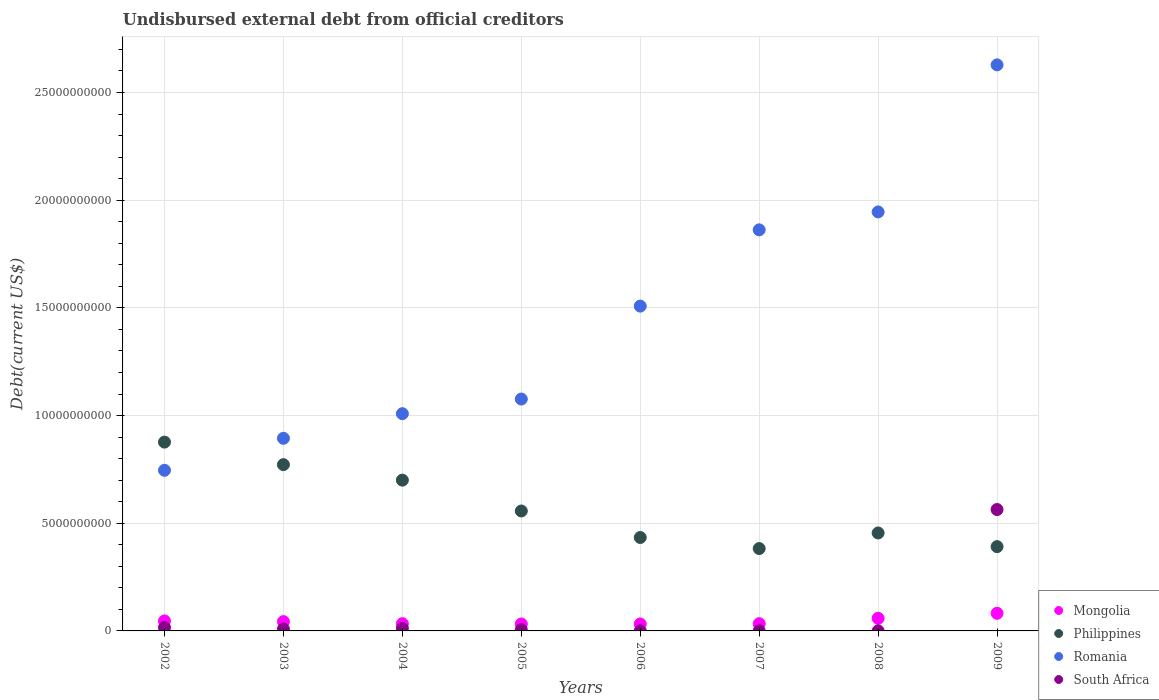What is the total debt in South Africa in 2003?
Ensure brevity in your answer.  8.62e+07. Across all years, what is the maximum total debt in Philippines?
Offer a terse response. 8.77e+09. Across all years, what is the minimum total debt in Romania?
Make the answer very short. 7.46e+09. In which year was the total debt in Romania maximum?
Ensure brevity in your answer.  2009. In which year was the total debt in South Africa minimum?
Offer a terse response. 2008. What is the total total debt in South Africa in the graph?
Make the answer very short. 6.07e+09. What is the difference between the total debt in South Africa in 2003 and that in 2008?
Ensure brevity in your answer.  8.22e+07. What is the difference between the total debt in South Africa in 2003 and the total debt in Romania in 2009?
Make the answer very short. -2.62e+1. What is the average total debt in Mongolia per year?
Provide a succinct answer. 4.52e+08. In the year 2002, what is the difference between the total debt in Mongolia and total debt in South Africa?
Ensure brevity in your answer.  3.06e+08. In how many years, is the total debt in Philippines greater than 26000000000 US$?
Ensure brevity in your answer.  0. What is the ratio of the total debt in Mongolia in 2008 to that in 2009?
Make the answer very short. 0.72. Is the total debt in South Africa in 2002 less than that in 2004?
Offer a very short reply. No. What is the difference between the highest and the second highest total debt in Mongolia?
Ensure brevity in your answer.  2.33e+08. What is the difference between the highest and the lowest total debt in Romania?
Offer a very short reply. 1.88e+1. Is it the case that in every year, the sum of the total debt in Philippines and total debt in Romania  is greater than the total debt in South Africa?
Offer a very short reply. Yes. Is the total debt in Mongolia strictly less than the total debt in South Africa over the years?
Provide a short and direct response. No. Does the graph contain any zero values?
Your response must be concise. No. Does the graph contain grids?
Ensure brevity in your answer.  Yes. Where does the legend appear in the graph?
Provide a succinct answer. Bottom right. How are the legend labels stacked?
Offer a very short reply. Vertical. What is the title of the graph?
Make the answer very short. Undisbursed external debt from official creditors. Does "Austria" appear as one of the legend labels in the graph?
Offer a very short reply. No. What is the label or title of the Y-axis?
Your response must be concise. Debt(current US$). What is the Debt(current US$) in Mongolia in 2002?
Provide a short and direct response. 4.64e+08. What is the Debt(current US$) in Philippines in 2002?
Keep it short and to the point. 8.77e+09. What is the Debt(current US$) of Romania in 2002?
Your response must be concise. 7.46e+09. What is the Debt(current US$) in South Africa in 2002?
Ensure brevity in your answer.  1.59e+08. What is the Debt(current US$) of Mongolia in 2003?
Provide a short and direct response. 4.32e+08. What is the Debt(current US$) of Philippines in 2003?
Offer a very short reply. 7.72e+09. What is the Debt(current US$) of Romania in 2003?
Provide a succinct answer. 8.94e+09. What is the Debt(current US$) in South Africa in 2003?
Provide a short and direct response. 8.62e+07. What is the Debt(current US$) of Mongolia in 2004?
Your answer should be very brief. 3.35e+08. What is the Debt(current US$) in Philippines in 2004?
Ensure brevity in your answer.  7.00e+09. What is the Debt(current US$) of Romania in 2004?
Offer a very short reply. 1.01e+1. What is the Debt(current US$) of South Africa in 2004?
Make the answer very short. 1.16e+08. What is the Debt(current US$) in Mongolia in 2005?
Your answer should be very brief. 3.22e+08. What is the Debt(current US$) of Philippines in 2005?
Offer a very short reply. 5.57e+09. What is the Debt(current US$) in Romania in 2005?
Provide a succinct answer. 1.08e+1. What is the Debt(current US$) of South Africa in 2005?
Provide a short and direct response. 5.70e+07. What is the Debt(current US$) of Mongolia in 2006?
Offer a very short reply. 3.22e+08. What is the Debt(current US$) in Philippines in 2006?
Make the answer very short. 4.34e+09. What is the Debt(current US$) in Romania in 2006?
Your answer should be very brief. 1.51e+1. What is the Debt(current US$) in South Africa in 2006?
Give a very brief answer. 7.04e+06. What is the Debt(current US$) of Mongolia in 2007?
Provide a succinct answer. 3.36e+08. What is the Debt(current US$) of Philippines in 2007?
Give a very brief answer. 3.82e+09. What is the Debt(current US$) in Romania in 2007?
Make the answer very short. 1.86e+1. What is the Debt(current US$) of South Africa in 2007?
Offer a very short reply. 7.04e+06. What is the Debt(current US$) of Mongolia in 2008?
Provide a short and direct response. 5.85e+08. What is the Debt(current US$) in Philippines in 2008?
Your answer should be compact. 4.55e+09. What is the Debt(current US$) of Romania in 2008?
Keep it short and to the point. 1.95e+1. What is the Debt(current US$) in South Africa in 2008?
Offer a terse response. 3.94e+06. What is the Debt(current US$) of Mongolia in 2009?
Offer a very short reply. 8.19e+08. What is the Debt(current US$) of Philippines in 2009?
Keep it short and to the point. 3.91e+09. What is the Debt(current US$) in Romania in 2009?
Provide a short and direct response. 2.63e+1. What is the Debt(current US$) in South Africa in 2009?
Provide a succinct answer. 5.64e+09. Across all years, what is the maximum Debt(current US$) in Mongolia?
Offer a very short reply. 8.19e+08. Across all years, what is the maximum Debt(current US$) of Philippines?
Your answer should be very brief. 8.77e+09. Across all years, what is the maximum Debt(current US$) in Romania?
Provide a succinct answer. 2.63e+1. Across all years, what is the maximum Debt(current US$) of South Africa?
Ensure brevity in your answer.  5.64e+09. Across all years, what is the minimum Debt(current US$) in Mongolia?
Offer a very short reply. 3.22e+08. Across all years, what is the minimum Debt(current US$) in Philippines?
Your answer should be very brief. 3.82e+09. Across all years, what is the minimum Debt(current US$) of Romania?
Provide a short and direct response. 7.46e+09. Across all years, what is the minimum Debt(current US$) in South Africa?
Give a very brief answer. 3.94e+06. What is the total Debt(current US$) in Mongolia in the graph?
Offer a terse response. 3.62e+09. What is the total Debt(current US$) in Philippines in the graph?
Your response must be concise. 4.57e+1. What is the total Debt(current US$) of Romania in the graph?
Keep it short and to the point. 1.17e+11. What is the total Debt(current US$) of South Africa in the graph?
Make the answer very short. 6.07e+09. What is the difference between the Debt(current US$) in Mongolia in 2002 and that in 2003?
Your answer should be very brief. 3.22e+07. What is the difference between the Debt(current US$) in Philippines in 2002 and that in 2003?
Provide a succinct answer. 1.05e+09. What is the difference between the Debt(current US$) in Romania in 2002 and that in 2003?
Keep it short and to the point. -1.49e+09. What is the difference between the Debt(current US$) of South Africa in 2002 and that in 2003?
Ensure brevity in your answer.  7.24e+07. What is the difference between the Debt(current US$) in Mongolia in 2002 and that in 2004?
Ensure brevity in your answer.  1.29e+08. What is the difference between the Debt(current US$) in Philippines in 2002 and that in 2004?
Your answer should be compact. 1.77e+09. What is the difference between the Debt(current US$) of Romania in 2002 and that in 2004?
Provide a short and direct response. -2.63e+09. What is the difference between the Debt(current US$) in South Africa in 2002 and that in 2004?
Give a very brief answer. 4.22e+07. What is the difference between the Debt(current US$) in Mongolia in 2002 and that in 2005?
Offer a very short reply. 1.42e+08. What is the difference between the Debt(current US$) of Philippines in 2002 and that in 2005?
Your answer should be compact. 3.20e+09. What is the difference between the Debt(current US$) in Romania in 2002 and that in 2005?
Ensure brevity in your answer.  -3.31e+09. What is the difference between the Debt(current US$) in South Africa in 2002 and that in 2005?
Provide a short and direct response. 1.02e+08. What is the difference between the Debt(current US$) in Mongolia in 2002 and that in 2006?
Keep it short and to the point. 1.42e+08. What is the difference between the Debt(current US$) in Philippines in 2002 and that in 2006?
Your answer should be compact. 4.43e+09. What is the difference between the Debt(current US$) of Romania in 2002 and that in 2006?
Ensure brevity in your answer.  -7.62e+09. What is the difference between the Debt(current US$) of South Africa in 2002 and that in 2006?
Your answer should be compact. 1.52e+08. What is the difference between the Debt(current US$) of Mongolia in 2002 and that in 2007?
Ensure brevity in your answer.  1.29e+08. What is the difference between the Debt(current US$) of Philippines in 2002 and that in 2007?
Your answer should be very brief. 4.94e+09. What is the difference between the Debt(current US$) of Romania in 2002 and that in 2007?
Your response must be concise. -1.12e+1. What is the difference between the Debt(current US$) of South Africa in 2002 and that in 2007?
Give a very brief answer. 1.52e+08. What is the difference between the Debt(current US$) of Mongolia in 2002 and that in 2008?
Provide a succinct answer. -1.21e+08. What is the difference between the Debt(current US$) of Philippines in 2002 and that in 2008?
Your answer should be compact. 4.22e+09. What is the difference between the Debt(current US$) in Romania in 2002 and that in 2008?
Keep it short and to the point. -1.20e+1. What is the difference between the Debt(current US$) in South Africa in 2002 and that in 2008?
Give a very brief answer. 1.55e+08. What is the difference between the Debt(current US$) in Mongolia in 2002 and that in 2009?
Keep it short and to the point. -3.55e+08. What is the difference between the Debt(current US$) in Philippines in 2002 and that in 2009?
Your answer should be very brief. 4.85e+09. What is the difference between the Debt(current US$) in Romania in 2002 and that in 2009?
Make the answer very short. -1.88e+1. What is the difference between the Debt(current US$) of South Africa in 2002 and that in 2009?
Ensure brevity in your answer.  -5.48e+09. What is the difference between the Debt(current US$) of Mongolia in 2003 and that in 2004?
Provide a short and direct response. 9.66e+07. What is the difference between the Debt(current US$) in Philippines in 2003 and that in 2004?
Your answer should be very brief. 7.19e+08. What is the difference between the Debt(current US$) in Romania in 2003 and that in 2004?
Provide a succinct answer. -1.14e+09. What is the difference between the Debt(current US$) of South Africa in 2003 and that in 2004?
Offer a terse response. -3.02e+07. What is the difference between the Debt(current US$) in Mongolia in 2003 and that in 2005?
Your response must be concise. 1.10e+08. What is the difference between the Debt(current US$) of Philippines in 2003 and that in 2005?
Make the answer very short. 2.15e+09. What is the difference between the Debt(current US$) of Romania in 2003 and that in 2005?
Provide a short and direct response. -1.82e+09. What is the difference between the Debt(current US$) in South Africa in 2003 and that in 2005?
Provide a succinct answer. 2.91e+07. What is the difference between the Debt(current US$) of Mongolia in 2003 and that in 2006?
Ensure brevity in your answer.  1.10e+08. What is the difference between the Debt(current US$) of Philippines in 2003 and that in 2006?
Your answer should be very brief. 3.38e+09. What is the difference between the Debt(current US$) of Romania in 2003 and that in 2006?
Offer a very short reply. -6.14e+09. What is the difference between the Debt(current US$) in South Africa in 2003 and that in 2006?
Offer a very short reply. 7.91e+07. What is the difference between the Debt(current US$) of Mongolia in 2003 and that in 2007?
Your response must be concise. 9.64e+07. What is the difference between the Debt(current US$) in Philippines in 2003 and that in 2007?
Your answer should be very brief. 3.90e+09. What is the difference between the Debt(current US$) of Romania in 2003 and that in 2007?
Keep it short and to the point. -9.68e+09. What is the difference between the Debt(current US$) of South Africa in 2003 and that in 2007?
Offer a very short reply. 7.91e+07. What is the difference between the Debt(current US$) of Mongolia in 2003 and that in 2008?
Provide a short and direct response. -1.54e+08. What is the difference between the Debt(current US$) of Philippines in 2003 and that in 2008?
Ensure brevity in your answer.  3.17e+09. What is the difference between the Debt(current US$) of Romania in 2003 and that in 2008?
Offer a very short reply. -1.05e+1. What is the difference between the Debt(current US$) in South Africa in 2003 and that in 2008?
Your answer should be compact. 8.22e+07. What is the difference between the Debt(current US$) in Mongolia in 2003 and that in 2009?
Your response must be concise. -3.87e+08. What is the difference between the Debt(current US$) in Philippines in 2003 and that in 2009?
Your answer should be very brief. 3.81e+09. What is the difference between the Debt(current US$) of Romania in 2003 and that in 2009?
Your response must be concise. -1.73e+1. What is the difference between the Debt(current US$) of South Africa in 2003 and that in 2009?
Offer a very short reply. -5.55e+09. What is the difference between the Debt(current US$) of Mongolia in 2004 and that in 2005?
Your answer should be very brief. 1.33e+07. What is the difference between the Debt(current US$) of Philippines in 2004 and that in 2005?
Ensure brevity in your answer.  1.43e+09. What is the difference between the Debt(current US$) in Romania in 2004 and that in 2005?
Your answer should be compact. -6.80e+08. What is the difference between the Debt(current US$) of South Africa in 2004 and that in 2005?
Your answer should be compact. 5.94e+07. What is the difference between the Debt(current US$) in Mongolia in 2004 and that in 2006?
Ensure brevity in your answer.  1.32e+07. What is the difference between the Debt(current US$) in Philippines in 2004 and that in 2006?
Make the answer very short. 2.66e+09. What is the difference between the Debt(current US$) in Romania in 2004 and that in 2006?
Keep it short and to the point. -4.99e+09. What is the difference between the Debt(current US$) of South Africa in 2004 and that in 2006?
Ensure brevity in your answer.  1.09e+08. What is the difference between the Debt(current US$) in Mongolia in 2004 and that in 2007?
Keep it short and to the point. -2.40e+05. What is the difference between the Debt(current US$) of Philippines in 2004 and that in 2007?
Give a very brief answer. 3.18e+09. What is the difference between the Debt(current US$) of Romania in 2004 and that in 2007?
Offer a terse response. -8.54e+09. What is the difference between the Debt(current US$) of South Africa in 2004 and that in 2007?
Offer a very short reply. 1.09e+08. What is the difference between the Debt(current US$) of Mongolia in 2004 and that in 2008?
Your answer should be very brief. -2.50e+08. What is the difference between the Debt(current US$) of Philippines in 2004 and that in 2008?
Your response must be concise. 2.45e+09. What is the difference between the Debt(current US$) in Romania in 2004 and that in 2008?
Provide a succinct answer. -9.37e+09. What is the difference between the Debt(current US$) of South Africa in 2004 and that in 2008?
Offer a terse response. 1.12e+08. What is the difference between the Debt(current US$) of Mongolia in 2004 and that in 2009?
Give a very brief answer. -4.83e+08. What is the difference between the Debt(current US$) in Philippines in 2004 and that in 2009?
Give a very brief answer. 3.09e+09. What is the difference between the Debt(current US$) of Romania in 2004 and that in 2009?
Ensure brevity in your answer.  -1.62e+1. What is the difference between the Debt(current US$) in South Africa in 2004 and that in 2009?
Your answer should be compact. -5.52e+09. What is the difference between the Debt(current US$) of Mongolia in 2005 and that in 2006?
Your response must be concise. -1.44e+05. What is the difference between the Debt(current US$) of Philippines in 2005 and that in 2006?
Give a very brief answer. 1.23e+09. What is the difference between the Debt(current US$) in Romania in 2005 and that in 2006?
Offer a very short reply. -4.31e+09. What is the difference between the Debt(current US$) in Mongolia in 2005 and that in 2007?
Your answer should be very brief. -1.35e+07. What is the difference between the Debt(current US$) of Philippines in 2005 and that in 2007?
Provide a short and direct response. 1.74e+09. What is the difference between the Debt(current US$) in Romania in 2005 and that in 2007?
Offer a very short reply. -7.86e+09. What is the difference between the Debt(current US$) in South Africa in 2005 and that in 2007?
Your answer should be very brief. 5.00e+07. What is the difference between the Debt(current US$) of Mongolia in 2005 and that in 2008?
Your answer should be compact. -2.63e+08. What is the difference between the Debt(current US$) in Philippines in 2005 and that in 2008?
Your answer should be compact. 1.02e+09. What is the difference between the Debt(current US$) of Romania in 2005 and that in 2008?
Give a very brief answer. -8.69e+09. What is the difference between the Debt(current US$) of South Africa in 2005 and that in 2008?
Provide a succinct answer. 5.31e+07. What is the difference between the Debt(current US$) in Mongolia in 2005 and that in 2009?
Provide a succinct answer. -4.97e+08. What is the difference between the Debt(current US$) in Philippines in 2005 and that in 2009?
Ensure brevity in your answer.  1.65e+09. What is the difference between the Debt(current US$) of Romania in 2005 and that in 2009?
Ensure brevity in your answer.  -1.55e+1. What is the difference between the Debt(current US$) of South Africa in 2005 and that in 2009?
Provide a succinct answer. -5.58e+09. What is the difference between the Debt(current US$) of Mongolia in 2006 and that in 2007?
Provide a short and direct response. -1.34e+07. What is the difference between the Debt(current US$) in Philippines in 2006 and that in 2007?
Keep it short and to the point. 5.13e+08. What is the difference between the Debt(current US$) in Romania in 2006 and that in 2007?
Offer a terse response. -3.54e+09. What is the difference between the Debt(current US$) in South Africa in 2006 and that in 2007?
Ensure brevity in your answer.  0. What is the difference between the Debt(current US$) of Mongolia in 2006 and that in 2008?
Make the answer very short. -2.63e+08. What is the difference between the Debt(current US$) of Philippines in 2006 and that in 2008?
Make the answer very short. -2.11e+08. What is the difference between the Debt(current US$) in Romania in 2006 and that in 2008?
Keep it short and to the point. -4.37e+09. What is the difference between the Debt(current US$) in South Africa in 2006 and that in 2008?
Give a very brief answer. 3.10e+06. What is the difference between the Debt(current US$) of Mongolia in 2006 and that in 2009?
Provide a short and direct response. -4.97e+08. What is the difference between the Debt(current US$) in Philippines in 2006 and that in 2009?
Offer a terse response. 4.24e+08. What is the difference between the Debt(current US$) of Romania in 2006 and that in 2009?
Your answer should be very brief. -1.12e+1. What is the difference between the Debt(current US$) of South Africa in 2006 and that in 2009?
Keep it short and to the point. -5.63e+09. What is the difference between the Debt(current US$) of Mongolia in 2007 and that in 2008?
Provide a succinct answer. -2.50e+08. What is the difference between the Debt(current US$) in Philippines in 2007 and that in 2008?
Your answer should be compact. -7.24e+08. What is the difference between the Debt(current US$) in Romania in 2007 and that in 2008?
Offer a very short reply. -8.32e+08. What is the difference between the Debt(current US$) in South Africa in 2007 and that in 2008?
Give a very brief answer. 3.10e+06. What is the difference between the Debt(current US$) in Mongolia in 2007 and that in 2009?
Offer a terse response. -4.83e+08. What is the difference between the Debt(current US$) of Philippines in 2007 and that in 2009?
Your answer should be very brief. -8.90e+07. What is the difference between the Debt(current US$) of Romania in 2007 and that in 2009?
Your answer should be compact. -7.66e+09. What is the difference between the Debt(current US$) of South Africa in 2007 and that in 2009?
Your answer should be very brief. -5.63e+09. What is the difference between the Debt(current US$) of Mongolia in 2008 and that in 2009?
Provide a short and direct response. -2.33e+08. What is the difference between the Debt(current US$) in Philippines in 2008 and that in 2009?
Give a very brief answer. 6.35e+08. What is the difference between the Debt(current US$) of Romania in 2008 and that in 2009?
Provide a short and direct response. -6.83e+09. What is the difference between the Debt(current US$) in South Africa in 2008 and that in 2009?
Your answer should be compact. -5.63e+09. What is the difference between the Debt(current US$) in Mongolia in 2002 and the Debt(current US$) in Philippines in 2003?
Offer a very short reply. -7.26e+09. What is the difference between the Debt(current US$) in Mongolia in 2002 and the Debt(current US$) in Romania in 2003?
Keep it short and to the point. -8.48e+09. What is the difference between the Debt(current US$) of Mongolia in 2002 and the Debt(current US$) of South Africa in 2003?
Keep it short and to the point. 3.78e+08. What is the difference between the Debt(current US$) of Philippines in 2002 and the Debt(current US$) of Romania in 2003?
Offer a terse response. -1.77e+08. What is the difference between the Debt(current US$) in Philippines in 2002 and the Debt(current US$) in South Africa in 2003?
Your answer should be very brief. 8.68e+09. What is the difference between the Debt(current US$) in Romania in 2002 and the Debt(current US$) in South Africa in 2003?
Make the answer very short. 7.37e+09. What is the difference between the Debt(current US$) in Mongolia in 2002 and the Debt(current US$) in Philippines in 2004?
Give a very brief answer. -6.54e+09. What is the difference between the Debt(current US$) in Mongolia in 2002 and the Debt(current US$) in Romania in 2004?
Give a very brief answer. -9.62e+09. What is the difference between the Debt(current US$) of Mongolia in 2002 and the Debt(current US$) of South Africa in 2004?
Keep it short and to the point. 3.48e+08. What is the difference between the Debt(current US$) of Philippines in 2002 and the Debt(current US$) of Romania in 2004?
Your answer should be very brief. -1.32e+09. What is the difference between the Debt(current US$) of Philippines in 2002 and the Debt(current US$) of South Africa in 2004?
Offer a terse response. 8.65e+09. What is the difference between the Debt(current US$) in Romania in 2002 and the Debt(current US$) in South Africa in 2004?
Ensure brevity in your answer.  7.34e+09. What is the difference between the Debt(current US$) in Mongolia in 2002 and the Debt(current US$) in Philippines in 2005?
Your response must be concise. -5.10e+09. What is the difference between the Debt(current US$) of Mongolia in 2002 and the Debt(current US$) of Romania in 2005?
Your response must be concise. -1.03e+1. What is the difference between the Debt(current US$) in Mongolia in 2002 and the Debt(current US$) in South Africa in 2005?
Your answer should be compact. 4.07e+08. What is the difference between the Debt(current US$) of Philippines in 2002 and the Debt(current US$) of Romania in 2005?
Offer a terse response. -2.00e+09. What is the difference between the Debt(current US$) of Philippines in 2002 and the Debt(current US$) of South Africa in 2005?
Give a very brief answer. 8.71e+09. What is the difference between the Debt(current US$) of Romania in 2002 and the Debt(current US$) of South Africa in 2005?
Offer a very short reply. 7.40e+09. What is the difference between the Debt(current US$) of Mongolia in 2002 and the Debt(current US$) of Philippines in 2006?
Your answer should be compact. -3.87e+09. What is the difference between the Debt(current US$) in Mongolia in 2002 and the Debt(current US$) in Romania in 2006?
Provide a succinct answer. -1.46e+1. What is the difference between the Debt(current US$) of Mongolia in 2002 and the Debt(current US$) of South Africa in 2006?
Ensure brevity in your answer.  4.57e+08. What is the difference between the Debt(current US$) in Philippines in 2002 and the Debt(current US$) in Romania in 2006?
Give a very brief answer. -6.31e+09. What is the difference between the Debt(current US$) in Philippines in 2002 and the Debt(current US$) in South Africa in 2006?
Give a very brief answer. 8.76e+09. What is the difference between the Debt(current US$) of Romania in 2002 and the Debt(current US$) of South Africa in 2006?
Provide a short and direct response. 7.45e+09. What is the difference between the Debt(current US$) of Mongolia in 2002 and the Debt(current US$) of Philippines in 2007?
Your answer should be very brief. -3.36e+09. What is the difference between the Debt(current US$) in Mongolia in 2002 and the Debt(current US$) in Romania in 2007?
Give a very brief answer. -1.82e+1. What is the difference between the Debt(current US$) of Mongolia in 2002 and the Debt(current US$) of South Africa in 2007?
Provide a short and direct response. 4.57e+08. What is the difference between the Debt(current US$) in Philippines in 2002 and the Debt(current US$) in Romania in 2007?
Ensure brevity in your answer.  -9.86e+09. What is the difference between the Debt(current US$) in Philippines in 2002 and the Debt(current US$) in South Africa in 2007?
Offer a terse response. 8.76e+09. What is the difference between the Debt(current US$) in Romania in 2002 and the Debt(current US$) in South Africa in 2007?
Keep it short and to the point. 7.45e+09. What is the difference between the Debt(current US$) of Mongolia in 2002 and the Debt(current US$) of Philippines in 2008?
Provide a short and direct response. -4.08e+09. What is the difference between the Debt(current US$) of Mongolia in 2002 and the Debt(current US$) of Romania in 2008?
Provide a short and direct response. -1.90e+1. What is the difference between the Debt(current US$) in Mongolia in 2002 and the Debt(current US$) in South Africa in 2008?
Offer a terse response. 4.60e+08. What is the difference between the Debt(current US$) of Philippines in 2002 and the Debt(current US$) of Romania in 2008?
Your answer should be compact. -1.07e+1. What is the difference between the Debt(current US$) in Philippines in 2002 and the Debt(current US$) in South Africa in 2008?
Offer a very short reply. 8.76e+09. What is the difference between the Debt(current US$) in Romania in 2002 and the Debt(current US$) in South Africa in 2008?
Give a very brief answer. 7.45e+09. What is the difference between the Debt(current US$) in Mongolia in 2002 and the Debt(current US$) in Philippines in 2009?
Provide a succinct answer. -3.45e+09. What is the difference between the Debt(current US$) of Mongolia in 2002 and the Debt(current US$) of Romania in 2009?
Give a very brief answer. -2.58e+1. What is the difference between the Debt(current US$) of Mongolia in 2002 and the Debt(current US$) of South Africa in 2009?
Offer a terse response. -5.17e+09. What is the difference between the Debt(current US$) in Philippines in 2002 and the Debt(current US$) in Romania in 2009?
Offer a very short reply. -1.75e+1. What is the difference between the Debt(current US$) of Philippines in 2002 and the Debt(current US$) of South Africa in 2009?
Keep it short and to the point. 3.13e+09. What is the difference between the Debt(current US$) of Romania in 2002 and the Debt(current US$) of South Africa in 2009?
Make the answer very short. 1.82e+09. What is the difference between the Debt(current US$) in Mongolia in 2003 and the Debt(current US$) in Philippines in 2004?
Ensure brevity in your answer.  -6.57e+09. What is the difference between the Debt(current US$) of Mongolia in 2003 and the Debt(current US$) of Romania in 2004?
Provide a succinct answer. -9.65e+09. What is the difference between the Debt(current US$) of Mongolia in 2003 and the Debt(current US$) of South Africa in 2004?
Provide a succinct answer. 3.16e+08. What is the difference between the Debt(current US$) of Philippines in 2003 and the Debt(current US$) of Romania in 2004?
Ensure brevity in your answer.  -2.37e+09. What is the difference between the Debt(current US$) in Philippines in 2003 and the Debt(current US$) in South Africa in 2004?
Your answer should be very brief. 7.60e+09. What is the difference between the Debt(current US$) of Romania in 2003 and the Debt(current US$) of South Africa in 2004?
Ensure brevity in your answer.  8.83e+09. What is the difference between the Debt(current US$) of Mongolia in 2003 and the Debt(current US$) of Philippines in 2005?
Make the answer very short. -5.14e+09. What is the difference between the Debt(current US$) of Mongolia in 2003 and the Debt(current US$) of Romania in 2005?
Your answer should be very brief. -1.03e+1. What is the difference between the Debt(current US$) of Mongolia in 2003 and the Debt(current US$) of South Africa in 2005?
Provide a short and direct response. 3.75e+08. What is the difference between the Debt(current US$) of Philippines in 2003 and the Debt(current US$) of Romania in 2005?
Provide a succinct answer. -3.05e+09. What is the difference between the Debt(current US$) in Philippines in 2003 and the Debt(current US$) in South Africa in 2005?
Offer a terse response. 7.66e+09. What is the difference between the Debt(current US$) of Romania in 2003 and the Debt(current US$) of South Africa in 2005?
Give a very brief answer. 8.89e+09. What is the difference between the Debt(current US$) in Mongolia in 2003 and the Debt(current US$) in Philippines in 2006?
Your answer should be compact. -3.91e+09. What is the difference between the Debt(current US$) in Mongolia in 2003 and the Debt(current US$) in Romania in 2006?
Make the answer very short. -1.46e+1. What is the difference between the Debt(current US$) in Mongolia in 2003 and the Debt(current US$) in South Africa in 2006?
Give a very brief answer. 4.25e+08. What is the difference between the Debt(current US$) of Philippines in 2003 and the Debt(current US$) of Romania in 2006?
Offer a very short reply. -7.36e+09. What is the difference between the Debt(current US$) of Philippines in 2003 and the Debt(current US$) of South Africa in 2006?
Give a very brief answer. 7.71e+09. What is the difference between the Debt(current US$) of Romania in 2003 and the Debt(current US$) of South Africa in 2006?
Give a very brief answer. 8.94e+09. What is the difference between the Debt(current US$) in Mongolia in 2003 and the Debt(current US$) in Philippines in 2007?
Offer a terse response. -3.39e+09. What is the difference between the Debt(current US$) of Mongolia in 2003 and the Debt(current US$) of Romania in 2007?
Offer a terse response. -1.82e+1. What is the difference between the Debt(current US$) of Mongolia in 2003 and the Debt(current US$) of South Africa in 2007?
Make the answer very short. 4.25e+08. What is the difference between the Debt(current US$) of Philippines in 2003 and the Debt(current US$) of Romania in 2007?
Provide a succinct answer. -1.09e+1. What is the difference between the Debt(current US$) of Philippines in 2003 and the Debt(current US$) of South Africa in 2007?
Your response must be concise. 7.71e+09. What is the difference between the Debt(current US$) in Romania in 2003 and the Debt(current US$) in South Africa in 2007?
Keep it short and to the point. 8.94e+09. What is the difference between the Debt(current US$) of Mongolia in 2003 and the Debt(current US$) of Philippines in 2008?
Your response must be concise. -4.12e+09. What is the difference between the Debt(current US$) of Mongolia in 2003 and the Debt(current US$) of Romania in 2008?
Keep it short and to the point. -1.90e+1. What is the difference between the Debt(current US$) of Mongolia in 2003 and the Debt(current US$) of South Africa in 2008?
Ensure brevity in your answer.  4.28e+08. What is the difference between the Debt(current US$) of Philippines in 2003 and the Debt(current US$) of Romania in 2008?
Your answer should be compact. -1.17e+1. What is the difference between the Debt(current US$) in Philippines in 2003 and the Debt(current US$) in South Africa in 2008?
Your answer should be compact. 7.72e+09. What is the difference between the Debt(current US$) of Romania in 2003 and the Debt(current US$) of South Africa in 2008?
Offer a very short reply. 8.94e+09. What is the difference between the Debt(current US$) of Mongolia in 2003 and the Debt(current US$) of Philippines in 2009?
Provide a short and direct response. -3.48e+09. What is the difference between the Debt(current US$) of Mongolia in 2003 and the Debt(current US$) of Romania in 2009?
Your answer should be compact. -2.59e+1. What is the difference between the Debt(current US$) in Mongolia in 2003 and the Debt(current US$) in South Africa in 2009?
Give a very brief answer. -5.20e+09. What is the difference between the Debt(current US$) of Philippines in 2003 and the Debt(current US$) of Romania in 2009?
Provide a succinct answer. -1.86e+1. What is the difference between the Debt(current US$) in Philippines in 2003 and the Debt(current US$) in South Africa in 2009?
Offer a very short reply. 2.08e+09. What is the difference between the Debt(current US$) in Romania in 2003 and the Debt(current US$) in South Africa in 2009?
Your answer should be very brief. 3.31e+09. What is the difference between the Debt(current US$) in Mongolia in 2004 and the Debt(current US$) in Philippines in 2005?
Offer a very short reply. -5.23e+09. What is the difference between the Debt(current US$) in Mongolia in 2004 and the Debt(current US$) in Romania in 2005?
Ensure brevity in your answer.  -1.04e+1. What is the difference between the Debt(current US$) of Mongolia in 2004 and the Debt(current US$) of South Africa in 2005?
Offer a terse response. 2.78e+08. What is the difference between the Debt(current US$) in Philippines in 2004 and the Debt(current US$) in Romania in 2005?
Ensure brevity in your answer.  -3.76e+09. What is the difference between the Debt(current US$) in Philippines in 2004 and the Debt(current US$) in South Africa in 2005?
Offer a terse response. 6.94e+09. What is the difference between the Debt(current US$) of Romania in 2004 and the Debt(current US$) of South Africa in 2005?
Ensure brevity in your answer.  1.00e+1. What is the difference between the Debt(current US$) in Mongolia in 2004 and the Debt(current US$) in Philippines in 2006?
Keep it short and to the point. -4.00e+09. What is the difference between the Debt(current US$) of Mongolia in 2004 and the Debt(current US$) of Romania in 2006?
Provide a succinct answer. -1.47e+1. What is the difference between the Debt(current US$) in Mongolia in 2004 and the Debt(current US$) in South Africa in 2006?
Offer a very short reply. 3.28e+08. What is the difference between the Debt(current US$) of Philippines in 2004 and the Debt(current US$) of Romania in 2006?
Make the answer very short. -8.08e+09. What is the difference between the Debt(current US$) of Philippines in 2004 and the Debt(current US$) of South Africa in 2006?
Offer a terse response. 6.99e+09. What is the difference between the Debt(current US$) of Romania in 2004 and the Debt(current US$) of South Africa in 2006?
Keep it short and to the point. 1.01e+1. What is the difference between the Debt(current US$) of Mongolia in 2004 and the Debt(current US$) of Philippines in 2007?
Make the answer very short. -3.49e+09. What is the difference between the Debt(current US$) in Mongolia in 2004 and the Debt(current US$) in Romania in 2007?
Your answer should be very brief. -1.83e+1. What is the difference between the Debt(current US$) of Mongolia in 2004 and the Debt(current US$) of South Africa in 2007?
Provide a short and direct response. 3.28e+08. What is the difference between the Debt(current US$) of Philippines in 2004 and the Debt(current US$) of Romania in 2007?
Your answer should be very brief. -1.16e+1. What is the difference between the Debt(current US$) of Philippines in 2004 and the Debt(current US$) of South Africa in 2007?
Make the answer very short. 6.99e+09. What is the difference between the Debt(current US$) of Romania in 2004 and the Debt(current US$) of South Africa in 2007?
Your response must be concise. 1.01e+1. What is the difference between the Debt(current US$) in Mongolia in 2004 and the Debt(current US$) in Philippines in 2008?
Give a very brief answer. -4.21e+09. What is the difference between the Debt(current US$) of Mongolia in 2004 and the Debt(current US$) of Romania in 2008?
Your answer should be compact. -1.91e+1. What is the difference between the Debt(current US$) of Mongolia in 2004 and the Debt(current US$) of South Africa in 2008?
Provide a short and direct response. 3.31e+08. What is the difference between the Debt(current US$) in Philippines in 2004 and the Debt(current US$) in Romania in 2008?
Make the answer very short. -1.25e+1. What is the difference between the Debt(current US$) in Philippines in 2004 and the Debt(current US$) in South Africa in 2008?
Provide a succinct answer. 7.00e+09. What is the difference between the Debt(current US$) in Romania in 2004 and the Debt(current US$) in South Africa in 2008?
Ensure brevity in your answer.  1.01e+1. What is the difference between the Debt(current US$) of Mongolia in 2004 and the Debt(current US$) of Philippines in 2009?
Keep it short and to the point. -3.58e+09. What is the difference between the Debt(current US$) in Mongolia in 2004 and the Debt(current US$) in Romania in 2009?
Provide a succinct answer. -2.59e+1. What is the difference between the Debt(current US$) in Mongolia in 2004 and the Debt(current US$) in South Africa in 2009?
Your answer should be very brief. -5.30e+09. What is the difference between the Debt(current US$) of Philippines in 2004 and the Debt(current US$) of Romania in 2009?
Keep it short and to the point. -1.93e+1. What is the difference between the Debt(current US$) of Philippines in 2004 and the Debt(current US$) of South Africa in 2009?
Give a very brief answer. 1.37e+09. What is the difference between the Debt(current US$) of Romania in 2004 and the Debt(current US$) of South Africa in 2009?
Keep it short and to the point. 4.45e+09. What is the difference between the Debt(current US$) of Mongolia in 2005 and the Debt(current US$) of Philippines in 2006?
Keep it short and to the point. -4.02e+09. What is the difference between the Debt(current US$) of Mongolia in 2005 and the Debt(current US$) of Romania in 2006?
Provide a short and direct response. -1.48e+1. What is the difference between the Debt(current US$) in Mongolia in 2005 and the Debt(current US$) in South Africa in 2006?
Provide a succinct answer. 3.15e+08. What is the difference between the Debt(current US$) in Philippines in 2005 and the Debt(current US$) in Romania in 2006?
Offer a terse response. -9.51e+09. What is the difference between the Debt(current US$) in Philippines in 2005 and the Debt(current US$) in South Africa in 2006?
Offer a very short reply. 5.56e+09. What is the difference between the Debt(current US$) in Romania in 2005 and the Debt(current US$) in South Africa in 2006?
Offer a very short reply. 1.08e+1. What is the difference between the Debt(current US$) in Mongolia in 2005 and the Debt(current US$) in Philippines in 2007?
Offer a terse response. -3.50e+09. What is the difference between the Debt(current US$) in Mongolia in 2005 and the Debt(current US$) in Romania in 2007?
Ensure brevity in your answer.  -1.83e+1. What is the difference between the Debt(current US$) in Mongolia in 2005 and the Debt(current US$) in South Africa in 2007?
Provide a succinct answer. 3.15e+08. What is the difference between the Debt(current US$) of Philippines in 2005 and the Debt(current US$) of Romania in 2007?
Your answer should be compact. -1.31e+1. What is the difference between the Debt(current US$) in Philippines in 2005 and the Debt(current US$) in South Africa in 2007?
Provide a succinct answer. 5.56e+09. What is the difference between the Debt(current US$) of Romania in 2005 and the Debt(current US$) of South Africa in 2007?
Ensure brevity in your answer.  1.08e+1. What is the difference between the Debt(current US$) in Mongolia in 2005 and the Debt(current US$) in Philippines in 2008?
Provide a succinct answer. -4.23e+09. What is the difference between the Debt(current US$) of Mongolia in 2005 and the Debt(current US$) of Romania in 2008?
Ensure brevity in your answer.  -1.91e+1. What is the difference between the Debt(current US$) of Mongolia in 2005 and the Debt(current US$) of South Africa in 2008?
Your response must be concise. 3.18e+08. What is the difference between the Debt(current US$) of Philippines in 2005 and the Debt(current US$) of Romania in 2008?
Give a very brief answer. -1.39e+1. What is the difference between the Debt(current US$) of Philippines in 2005 and the Debt(current US$) of South Africa in 2008?
Give a very brief answer. 5.56e+09. What is the difference between the Debt(current US$) of Romania in 2005 and the Debt(current US$) of South Africa in 2008?
Offer a very short reply. 1.08e+1. What is the difference between the Debt(current US$) in Mongolia in 2005 and the Debt(current US$) in Philippines in 2009?
Give a very brief answer. -3.59e+09. What is the difference between the Debt(current US$) of Mongolia in 2005 and the Debt(current US$) of Romania in 2009?
Your answer should be compact. -2.60e+1. What is the difference between the Debt(current US$) of Mongolia in 2005 and the Debt(current US$) of South Africa in 2009?
Your answer should be very brief. -5.31e+09. What is the difference between the Debt(current US$) in Philippines in 2005 and the Debt(current US$) in Romania in 2009?
Provide a short and direct response. -2.07e+1. What is the difference between the Debt(current US$) of Philippines in 2005 and the Debt(current US$) of South Africa in 2009?
Your answer should be compact. -6.79e+07. What is the difference between the Debt(current US$) in Romania in 2005 and the Debt(current US$) in South Africa in 2009?
Offer a very short reply. 5.13e+09. What is the difference between the Debt(current US$) of Mongolia in 2006 and the Debt(current US$) of Philippines in 2007?
Provide a short and direct response. -3.50e+09. What is the difference between the Debt(current US$) of Mongolia in 2006 and the Debt(current US$) of Romania in 2007?
Offer a very short reply. -1.83e+1. What is the difference between the Debt(current US$) in Mongolia in 2006 and the Debt(current US$) in South Africa in 2007?
Ensure brevity in your answer.  3.15e+08. What is the difference between the Debt(current US$) in Philippines in 2006 and the Debt(current US$) in Romania in 2007?
Keep it short and to the point. -1.43e+1. What is the difference between the Debt(current US$) in Philippines in 2006 and the Debt(current US$) in South Africa in 2007?
Provide a succinct answer. 4.33e+09. What is the difference between the Debt(current US$) in Romania in 2006 and the Debt(current US$) in South Africa in 2007?
Ensure brevity in your answer.  1.51e+1. What is the difference between the Debt(current US$) of Mongolia in 2006 and the Debt(current US$) of Philippines in 2008?
Offer a terse response. -4.23e+09. What is the difference between the Debt(current US$) in Mongolia in 2006 and the Debt(current US$) in Romania in 2008?
Provide a succinct answer. -1.91e+1. What is the difference between the Debt(current US$) of Mongolia in 2006 and the Debt(current US$) of South Africa in 2008?
Keep it short and to the point. 3.18e+08. What is the difference between the Debt(current US$) in Philippines in 2006 and the Debt(current US$) in Romania in 2008?
Your answer should be very brief. -1.51e+1. What is the difference between the Debt(current US$) of Philippines in 2006 and the Debt(current US$) of South Africa in 2008?
Offer a very short reply. 4.33e+09. What is the difference between the Debt(current US$) in Romania in 2006 and the Debt(current US$) in South Africa in 2008?
Make the answer very short. 1.51e+1. What is the difference between the Debt(current US$) of Mongolia in 2006 and the Debt(current US$) of Philippines in 2009?
Keep it short and to the point. -3.59e+09. What is the difference between the Debt(current US$) in Mongolia in 2006 and the Debt(current US$) in Romania in 2009?
Your answer should be very brief. -2.60e+1. What is the difference between the Debt(current US$) in Mongolia in 2006 and the Debt(current US$) in South Africa in 2009?
Make the answer very short. -5.31e+09. What is the difference between the Debt(current US$) of Philippines in 2006 and the Debt(current US$) of Romania in 2009?
Ensure brevity in your answer.  -2.19e+1. What is the difference between the Debt(current US$) in Philippines in 2006 and the Debt(current US$) in South Africa in 2009?
Your answer should be compact. -1.30e+09. What is the difference between the Debt(current US$) in Romania in 2006 and the Debt(current US$) in South Africa in 2009?
Your answer should be very brief. 9.44e+09. What is the difference between the Debt(current US$) in Mongolia in 2007 and the Debt(current US$) in Philippines in 2008?
Offer a very short reply. -4.21e+09. What is the difference between the Debt(current US$) in Mongolia in 2007 and the Debt(current US$) in Romania in 2008?
Offer a very short reply. -1.91e+1. What is the difference between the Debt(current US$) in Mongolia in 2007 and the Debt(current US$) in South Africa in 2008?
Ensure brevity in your answer.  3.32e+08. What is the difference between the Debt(current US$) in Philippines in 2007 and the Debt(current US$) in Romania in 2008?
Offer a very short reply. -1.56e+1. What is the difference between the Debt(current US$) in Philippines in 2007 and the Debt(current US$) in South Africa in 2008?
Offer a very short reply. 3.82e+09. What is the difference between the Debt(current US$) in Romania in 2007 and the Debt(current US$) in South Africa in 2008?
Keep it short and to the point. 1.86e+1. What is the difference between the Debt(current US$) in Mongolia in 2007 and the Debt(current US$) in Philippines in 2009?
Make the answer very short. -3.58e+09. What is the difference between the Debt(current US$) in Mongolia in 2007 and the Debt(current US$) in Romania in 2009?
Offer a very short reply. -2.59e+1. What is the difference between the Debt(current US$) of Mongolia in 2007 and the Debt(current US$) of South Africa in 2009?
Your answer should be compact. -5.30e+09. What is the difference between the Debt(current US$) in Philippines in 2007 and the Debt(current US$) in Romania in 2009?
Your answer should be very brief. -2.25e+1. What is the difference between the Debt(current US$) in Philippines in 2007 and the Debt(current US$) in South Africa in 2009?
Make the answer very short. -1.81e+09. What is the difference between the Debt(current US$) of Romania in 2007 and the Debt(current US$) of South Africa in 2009?
Make the answer very short. 1.30e+1. What is the difference between the Debt(current US$) in Mongolia in 2008 and the Debt(current US$) in Philippines in 2009?
Provide a short and direct response. -3.33e+09. What is the difference between the Debt(current US$) of Mongolia in 2008 and the Debt(current US$) of Romania in 2009?
Provide a succinct answer. -2.57e+1. What is the difference between the Debt(current US$) in Mongolia in 2008 and the Debt(current US$) in South Africa in 2009?
Give a very brief answer. -5.05e+09. What is the difference between the Debt(current US$) of Philippines in 2008 and the Debt(current US$) of Romania in 2009?
Offer a very short reply. -2.17e+1. What is the difference between the Debt(current US$) in Philippines in 2008 and the Debt(current US$) in South Africa in 2009?
Your answer should be very brief. -1.09e+09. What is the difference between the Debt(current US$) in Romania in 2008 and the Debt(current US$) in South Africa in 2009?
Provide a succinct answer. 1.38e+1. What is the average Debt(current US$) in Mongolia per year?
Your answer should be compact. 4.52e+08. What is the average Debt(current US$) of Philippines per year?
Give a very brief answer. 5.71e+09. What is the average Debt(current US$) in Romania per year?
Keep it short and to the point. 1.46e+1. What is the average Debt(current US$) of South Africa per year?
Ensure brevity in your answer.  7.59e+08. In the year 2002, what is the difference between the Debt(current US$) of Mongolia and Debt(current US$) of Philippines?
Ensure brevity in your answer.  -8.30e+09. In the year 2002, what is the difference between the Debt(current US$) of Mongolia and Debt(current US$) of Romania?
Make the answer very short. -6.99e+09. In the year 2002, what is the difference between the Debt(current US$) of Mongolia and Debt(current US$) of South Africa?
Provide a short and direct response. 3.06e+08. In the year 2002, what is the difference between the Debt(current US$) in Philippines and Debt(current US$) in Romania?
Offer a very short reply. 1.31e+09. In the year 2002, what is the difference between the Debt(current US$) of Philippines and Debt(current US$) of South Africa?
Your answer should be very brief. 8.61e+09. In the year 2002, what is the difference between the Debt(current US$) of Romania and Debt(current US$) of South Africa?
Your answer should be compact. 7.30e+09. In the year 2003, what is the difference between the Debt(current US$) of Mongolia and Debt(current US$) of Philippines?
Offer a terse response. -7.29e+09. In the year 2003, what is the difference between the Debt(current US$) of Mongolia and Debt(current US$) of Romania?
Keep it short and to the point. -8.51e+09. In the year 2003, what is the difference between the Debt(current US$) in Mongolia and Debt(current US$) in South Africa?
Your answer should be compact. 3.46e+08. In the year 2003, what is the difference between the Debt(current US$) in Philippines and Debt(current US$) in Romania?
Your answer should be compact. -1.22e+09. In the year 2003, what is the difference between the Debt(current US$) in Philippines and Debt(current US$) in South Africa?
Your response must be concise. 7.63e+09. In the year 2003, what is the difference between the Debt(current US$) of Romania and Debt(current US$) of South Africa?
Keep it short and to the point. 8.86e+09. In the year 2004, what is the difference between the Debt(current US$) of Mongolia and Debt(current US$) of Philippines?
Provide a succinct answer. -6.67e+09. In the year 2004, what is the difference between the Debt(current US$) of Mongolia and Debt(current US$) of Romania?
Offer a very short reply. -9.75e+09. In the year 2004, what is the difference between the Debt(current US$) of Mongolia and Debt(current US$) of South Africa?
Ensure brevity in your answer.  2.19e+08. In the year 2004, what is the difference between the Debt(current US$) of Philippines and Debt(current US$) of Romania?
Offer a very short reply. -3.09e+09. In the year 2004, what is the difference between the Debt(current US$) in Philippines and Debt(current US$) in South Africa?
Your response must be concise. 6.88e+09. In the year 2004, what is the difference between the Debt(current US$) of Romania and Debt(current US$) of South Africa?
Make the answer very short. 9.97e+09. In the year 2005, what is the difference between the Debt(current US$) of Mongolia and Debt(current US$) of Philippines?
Provide a succinct answer. -5.25e+09. In the year 2005, what is the difference between the Debt(current US$) in Mongolia and Debt(current US$) in Romania?
Offer a terse response. -1.04e+1. In the year 2005, what is the difference between the Debt(current US$) of Mongolia and Debt(current US$) of South Africa?
Keep it short and to the point. 2.65e+08. In the year 2005, what is the difference between the Debt(current US$) in Philippines and Debt(current US$) in Romania?
Give a very brief answer. -5.20e+09. In the year 2005, what is the difference between the Debt(current US$) in Philippines and Debt(current US$) in South Africa?
Make the answer very short. 5.51e+09. In the year 2005, what is the difference between the Debt(current US$) of Romania and Debt(current US$) of South Africa?
Offer a very short reply. 1.07e+1. In the year 2006, what is the difference between the Debt(current US$) in Mongolia and Debt(current US$) in Philippines?
Provide a succinct answer. -4.02e+09. In the year 2006, what is the difference between the Debt(current US$) of Mongolia and Debt(current US$) of Romania?
Make the answer very short. -1.48e+1. In the year 2006, what is the difference between the Debt(current US$) in Mongolia and Debt(current US$) in South Africa?
Your response must be concise. 3.15e+08. In the year 2006, what is the difference between the Debt(current US$) in Philippines and Debt(current US$) in Romania?
Make the answer very short. -1.07e+1. In the year 2006, what is the difference between the Debt(current US$) in Philippines and Debt(current US$) in South Africa?
Provide a short and direct response. 4.33e+09. In the year 2006, what is the difference between the Debt(current US$) of Romania and Debt(current US$) of South Africa?
Make the answer very short. 1.51e+1. In the year 2007, what is the difference between the Debt(current US$) of Mongolia and Debt(current US$) of Philippines?
Provide a short and direct response. -3.49e+09. In the year 2007, what is the difference between the Debt(current US$) in Mongolia and Debt(current US$) in Romania?
Your response must be concise. -1.83e+1. In the year 2007, what is the difference between the Debt(current US$) of Mongolia and Debt(current US$) of South Africa?
Keep it short and to the point. 3.29e+08. In the year 2007, what is the difference between the Debt(current US$) in Philippines and Debt(current US$) in Romania?
Keep it short and to the point. -1.48e+1. In the year 2007, what is the difference between the Debt(current US$) in Philippines and Debt(current US$) in South Africa?
Your answer should be compact. 3.82e+09. In the year 2007, what is the difference between the Debt(current US$) in Romania and Debt(current US$) in South Africa?
Give a very brief answer. 1.86e+1. In the year 2008, what is the difference between the Debt(current US$) of Mongolia and Debt(current US$) of Philippines?
Ensure brevity in your answer.  -3.96e+09. In the year 2008, what is the difference between the Debt(current US$) in Mongolia and Debt(current US$) in Romania?
Keep it short and to the point. -1.89e+1. In the year 2008, what is the difference between the Debt(current US$) in Mongolia and Debt(current US$) in South Africa?
Give a very brief answer. 5.82e+08. In the year 2008, what is the difference between the Debt(current US$) of Philippines and Debt(current US$) of Romania?
Ensure brevity in your answer.  -1.49e+1. In the year 2008, what is the difference between the Debt(current US$) in Philippines and Debt(current US$) in South Africa?
Give a very brief answer. 4.54e+09. In the year 2008, what is the difference between the Debt(current US$) in Romania and Debt(current US$) in South Africa?
Keep it short and to the point. 1.95e+1. In the year 2009, what is the difference between the Debt(current US$) of Mongolia and Debt(current US$) of Philippines?
Make the answer very short. -3.09e+09. In the year 2009, what is the difference between the Debt(current US$) in Mongolia and Debt(current US$) in Romania?
Your answer should be compact. -2.55e+1. In the year 2009, what is the difference between the Debt(current US$) of Mongolia and Debt(current US$) of South Africa?
Your answer should be very brief. -4.82e+09. In the year 2009, what is the difference between the Debt(current US$) in Philippines and Debt(current US$) in Romania?
Give a very brief answer. -2.24e+1. In the year 2009, what is the difference between the Debt(current US$) in Philippines and Debt(current US$) in South Africa?
Keep it short and to the point. -1.72e+09. In the year 2009, what is the difference between the Debt(current US$) in Romania and Debt(current US$) in South Africa?
Offer a very short reply. 2.06e+1. What is the ratio of the Debt(current US$) of Mongolia in 2002 to that in 2003?
Your response must be concise. 1.07. What is the ratio of the Debt(current US$) in Philippines in 2002 to that in 2003?
Offer a very short reply. 1.14. What is the ratio of the Debt(current US$) of Romania in 2002 to that in 2003?
Your answer should be very brief. 0.83. What is the ratio of the Debt(current US$) in South Africa in 2002 to that in 2003?
Your answer should be very brief. 1.84. What is the ratio of the Debt(current US$) in Mongolia in 2002 to that in 2004?
Your response must be concise. 1.38. What is the ratio of the Debt(current US$) in Philippines in 2002 to that in 2004?
Your answer should be compact. 1.25. What is the ratio of the Debt(current US$) of Romania in 2002 to that in 2004?
Provide a succinct answer. 0.74. What is the ratio of the Debt(current US$) in South Africa in 2002 to that in 2004?
Give a very brief answer. 1.36. What is the ratio of the Debt(current US$) in Mongolia in 2002 to that in 2005?
Offer a very short reply. 1.44. What is the ratio of the Debt(current US$) of Philippines in 2002 to that in 2005?
Offer a very short reply. 1.57. What is the ratio of the Debt(current US$) of Romania in 2002 to that in 2005?
Your response must be concise. 0.69. What is the ratio of the Debt(current US$) of South Africa in 2002 to that in 2005?
Your answer should be compact. 2.78. What is the ratio of the Debt(current US$) of Mongolia in 2002 to that in 2006?
Give a very brief answer. 1.44. What is the ratio of the Debt(current US$) of Philippines in 2002 to that in 2006?
Provide a short and direct response. 2.02. What is the ratio of the Debt(current US$) in Romania in 2002 to that in 2006?
Your response must be concise. 0.49. What is the ratio of the Debt(current US$) in South Africa in 2002 to that in 2006?
Your answer should be compact. 22.53. What is the ratio of the Debt(current US$) in Mongolia in 2002 to that in 2007?
Your response must be concise. 1.38. What is the ratio of the Debt(current US$) of Philippines in 2002 to that in 2007?
Provide a succinct answer. 2.29. What is the ratio of the Debt(current US$) of Romania in 2002 to that in 2007?
Make the answer very short. 0.4. What is the ratio of the Debt(current US$) of South Africa in 2002 to that in 2007?
Your response must be concise. 22.53. What is the ratio of the Debt(current US$) of Mongolia in 2002 to that in 2008?
Ensure brevity in your answer.  0.79. What is the ratio of the Debt(current US$) in Philippines in 2002 to that in 2008?
Your answer should be very brief. 1.93. What is the ratio of the Debt(current US$) in Romania in 2002 to that in 2008?
Offer a terse response. 0.38. What is the ratio of the Debt(current US$) in South Africa in 2002 to that in 2008?
Make the answer very short. 40.29. What is the ratio of the Debt(current US$) in Mongolia in 2002 to that in 2009?
Offer a very short reply. 0.57. What is the ratio of the Debt(current US$) in Philippines in 2002 to that in 2009?
Offer a terse response. 2.24. What is the ratio of the Debt(current US$) in Romania in 2002 to that in 2009?
Make the answer very short. 0.28. What is the ratio of the Debt(current US$) in South Africa in 2002 to that in 2009?
Make the answer very short. 0.03. What is the ratio of the Debt(current US$) of Mongolia in 2003 to that in 2004?
Offer a very short reply. 1.29. What is the ratio of the Debt(current US$) in Philippines in 2003 to that in 2004?
Your answer should be very brief. 1.1. What is the ratio of the Debt(current US$) in Romania in 2003 to that in 2004?
Keep it short and to the point. 0.89. What is the ratio of the Debt(current US$) of South Africa in 2003 to that in 2004?
Offer a terse response. 0.74. What is the ratio of the Debt(current US$) in Mongolia in 2003 to that in 2005?
Offer a very short reply. 1.34. What is the ratio of the Debt(current US$) in Philippines in 2003 to that in 2005?
Give a very brief answer. 1.39. What is the ratio of the Debt(current US$) of Romania in 2003 to that in 2005?
Your answer should be compact. 0.83. What is the ratio of the Debt(current US$) of South Africa in 2003 to that in 2005?
Your answer should be compact. 1.51. What is the ratio of the Debt(current US$) of Mongolia in 2003 to that in 2006?
Ensure brevity in your answer.  1.34. What is the ratio of the Debt(current US$) in Philippines in 2003 to that in 2006?
Offer a terse response. 1.78. What is the ratio of the Debt(current US$) in Romania in 2003 to that in 2006?
Provide a succinct answer. 0.59. What is the ratio of the Debt(current US$) in South Africa in 2003 to that in 2006?
Provide a short and direct response. 12.24. What is the ratio of the Debt(current US$) in Mongolia in 2003 to that in 2007?
Offer a very short reply. 1.29. What is the ratio of the Debt(current US$) in Philippines in 2003 to that in 2007?
Keep it short and to the point. 2.02. What is the ratio of the Debt(current US$) in Romania in 2003 to that in 2007?
Ensure brevity in your answer.  0.48. What is the ratio of the Debt(current US$) in South Africa in 2003 to that in 2007?
Offer a very short reply. 12.24. What is the ratio of the Debt(current US$) in Mongolia in 2003 to that in 2008?
Your response must be concise. 0.74. What is the ratio of the Debt(current US$) of Philippines in 2003 to that in 2008?
Your answer should be compact. 1.7. What is the ratio of the Debt(current US$) of Romania in 2003 to that in 2008?
Keep it short and to the point. 0.46. What is the ratio of the Debt(current US$) in South Africa in 2003 to that in 2008?
Provide a short and direct response. 21.9. What is the ratio of the Debt(current US$) in Mongolia in 2003 to that in 2009?
Keep it short and to the point. 0.53. What is the ratio of the Debt(current US$) of Philippines in 2003 to that in 2009?
Provide a succinct answer. 1.97. What is the ratio of the Debt(current US$) of Romania in 2003 to that in 2009?
Make the answer very short. 0.34. What is the ratio of the Debt(current US$) in South Africa in 2003 to that in 2009?
Provide a short and direct response. 0.02. What is the ratio of the Debt(current US$) of Mongolia in 2004 to that in 2005?
Your response must be concise. 1.04. What is the ratio of the Debt(current US$) of Philippines in 2004 to that in 2005?
Give a very brief answer. 1.26. What is the ratio of the Debt(current US$) in Romania in 2004 to that in 2005?
Your answer should be compact. 0.94. What is the ratio of the Debt(current US$) in South Africa in 2004 to that in 2005?
Offer a terse response. 2.04. What is the ratio of the Debt(current US$) of Mongolia in 2004 to that in 2006?
Provide a short and direct response. 1.04. What is the ratio of the Debt(current US$) of Philippines in 2004 to that in 2006?
Provide a succinct answer. 1.61. What is the ratio of the Debt(current US$) of Romania in 2004 to that in 2006?
Your answer should be very brief. 0.67. What is the ratio of the Debt(current US$) in South Africa in 2004 to that in 2006?
Your answer should be compact. 16.54. What is the ratio of the Debt(current US$) of Philippines in 2004 to that in 2007?
Give a very brief answer. 1.83. What is the ratio of the Debt(current US$) in Romania in 2004 to that in 2007?
Provide a short and direct response. 0.54. What is the ratio of the Debt(current US$) in South Africa in 2004 to that in 2007?
Offer a terse response. 16.54. What is the ratio of the Debt(current US$) of Mongolia in 2004 to that in 2008?
Keep it short and to the point. 0.57. What is the ratio of the Debt(current US$) in Philippines in 2004 to that in 2008?
Give a very brief answer. 1.54. What is the ratio of the Debt(current US$) in Romania in 2004 to that in 2008?
Your response must be concise. 0.52. What is the ratio of the Debt(current US$) in South Africa in 2004 to that in 2008?
Ensure brevity in your answer.  29.58. What is the ratio of the Debt(current US$) in Mongolia in 2004 to that in 2009?
Keep it short and to the point. 0.41. What is the ratio of the Debt(current US$) in Philippines in 2004 to that in 2009?
Make the answer very short. 1.79. What is the ratio of the Debt(current US$) of Romania in 2004 to that in 2009?
Provide a short and direct response. 0.38. What is the ratio of the Debt(current US$) of South Africa in 2004 to that in 2009?
Your answer should be compact. 0.02. What is the ratio of the Debt(current US$) of Philippines in 2005 to that in 2006?
Provide a succinct answer. 1.28. What is the ratio of the Debt(current US$) of Romania in 2005 to that in 2006?
Your answer should be very brief. 0.71. What is the ratio of the Debt(current US$) of South Africa in 2005 to that in 2006?
Your answer should be very brief. 8.1. What is the ratio of the Debt(current US$) of Mongolia in 2005 to that in 2007?
Provide a succinct answer. 0.96. What is the ratio of the Debt(current US$) in Philippines in 2005 to that in 2007?
Give a very brief answer. 1.46. What is the ratio of the Debt(current US$) of Romania in 2005 to that in 2007?
Ensure brevity in your answer.  0.58. What is the ratio of the Debt(current US$) of South Africa in 2005 to that in 2007?
Give a very brief answer. 8.1. What is the ratio of the Debt(current US$) in Mongolia in 2005 to that in 2008?
Ensure brevity in your answer.  0.55. What is the ratio of the Debt(current US$) in Philippines in 2005 to that in 2008?
Give a very brief answer. 1.22. What is the ratio of the Debt(current US$) in Romania in 2005 to that in 2008?
Make the answer very short. 0.55. What is the ratio of the Debt(current US$) in South Africa in 2005 to that in 2008?
Your answer should be very brief. 14.49. What is the ratio of the Debt(current US$) in Mongolia in 2005 to that in 2009?
Provide a short and direct response. 0.39. What is the ratio of the Debt(current US$) of Philippines in 2005 to that in 2009?
Keep it short and to the point. 1.42. What is the ratio of the Debt(current US$) in Romania in 2005 to that in 2009?
Keep it short and to the point. 0.41. What is the ratio of the Debt(current US$) in South Africa in 2005 to that in 2009?
Your answer should be compact. 0.01. What is the ratio of the Debt(current US$) of Mongolia in 2006 to that in 2007?
Keep it short and to the point. 0.96. What is the ratio of the Debt(current US$) in Philippines in 2006 to that in 2007?
Give a very brief answer. 1.13. What is the ratio of the Debt(current US$) of Romania in 2006 to that in 2007?
Offer a terse response. 0.81. What is the ratio of the Debt(current US$) in South Africa in 2006 to that in 2007?
Your answer should be compact. 1. What is the ratio of the Debt(current US$) of Mongolia in 2006 to that in 2008?
Your answer should be very brief. 0.55. What is the ratio of the Debt(current US$) in Philippines in 2006 to that in 2008?
Ensure brevity in your answer.  0.95. What is the ratio of the Debt(current US$) of Romania in 2006 to that in 2008?
Your answer should be compact. 0.78. What is the ratio of the Debt(current US$) in South Africa in 2006 to that in 2008?
Provide a succinct answer. 1.79. What is the ratio of the Debt(current US$) in Mongolia in 2006 to that in 2009?
Your answer should be compact. 0.39. What is the ratio of the Debt(current US$) of Philippines in 2006 to that in 2009?
Give a very brief answer. 1.11. What is the ratio of the Debt(current US$) of Romania in 2006 to that in 2009?
Make the answer very short. 0.57. What is the ratio of the Debt(current US$) of South Africa in 2006 to that in 2009?
Keep it short and to the point. 0. What is the ratio of the Debt(current US$) in Mongolia in 2007 to that in 2008?
Keep it short and to the point. 0.57. What is the ratio of the Debt(current US$) in Philippines in 2007 to that in 2008?
Your response must be concise. 0.84. What is the ratio of the Debt(current US$) in Romania in 2007 to that in 2008?
Offer a very short reply. 0.96. What is the ratio of the Debt(current US$) of South Africa in 2007 to that in 2008?
Offer a very short reply. 1.79. What is the ratio of the Debt(current US$) in Mongolia in 2007 to that in 2009?
Offer a terse response. 0.41. What is the ratio of the Debt(current US$) in Philippines in 2007 to that in 2009?
Make the answer very short. 0.98. What is the ratio of the Debt(current US$) of Romania in 2007 to that in 2009?
Keep it short and to the point. 0.71. What is the ratio of the Debt(current US$) of South Africa in 2007 to that in 2009?
Ensure brevity in your answer.  0. What is the ratio of the Debt(current US$) of Mongolia in 2008 to that in 2009?
Give a very brief answer. 0.72. What is the ratio of the Debt(current US$) in Philippines in 2008 to that in 2009?
Your answer should be very brief. 1.16. What is the ratio of the Debt(current US$) in Romania in 2008 to that in 2009?
Provide a short and direct response. 0.74. What is the ratio of the Debt(current US$) in South Africa in 2008 to that in 2009?
Provide a succinct answer. 0. What is the difference between the highest and the second highest Debt(current US$) of Mongolia?
Give a very brief answer. 2.33e+08. What is the difference between the highest and the second highest Debt(current US$) of Philippines?
Offer a very short reply. 1.05e+09. What is the difference between the highest and the second highest Debt(current US$) of Romania?
Keep it short and to the point. 6.83e+09. What is the difference between the highest and the second highest Debt(current US$) of South Africa?
Offer a terse response. 5.48e+09. What is the difference between the highest and the lowest Debt(current US$) of Mongolia?
Provide a short and direct response. 4.97e+08. What is the difference between the highest and the lowest Debt(current US$) in Philippines?
Provide a succinct answer. 4.94e+09. What is the difference between the highest and the lowest Debt(current US$) of Romania?
Ensure brevity in your answer.  1.88e+1. What is the difference between the highest and the lowest Debt(current US$) in South Africa?
Ensure brevity in your answer.  5.63e+09. 